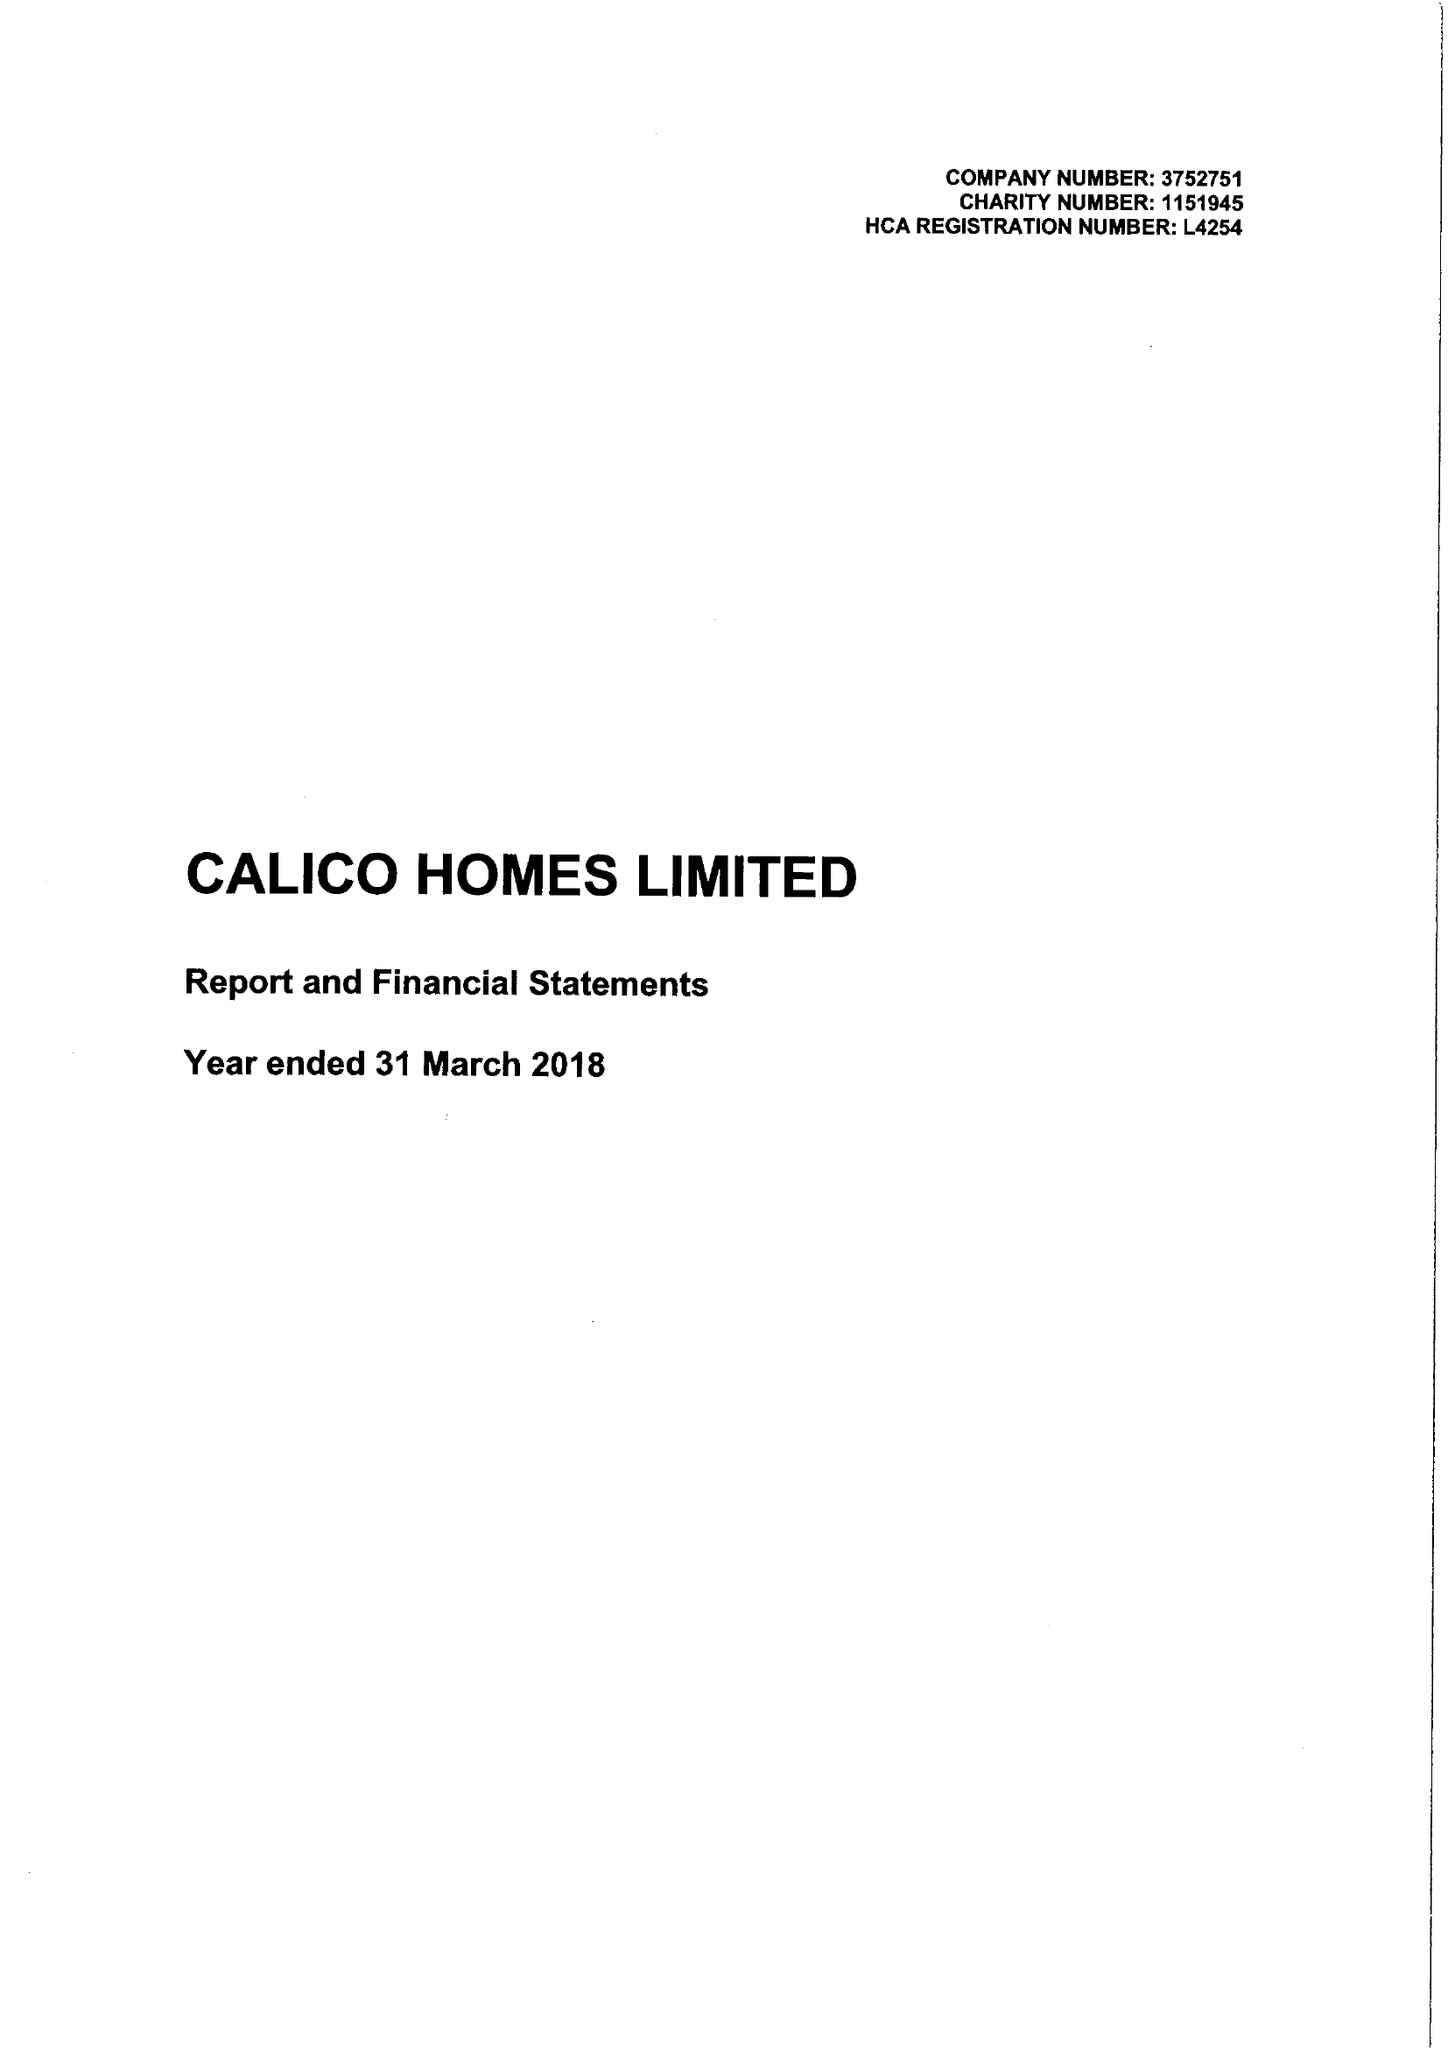What is the value for the report_date?
Answer the question using a single word or phrase. 2018-03-31 